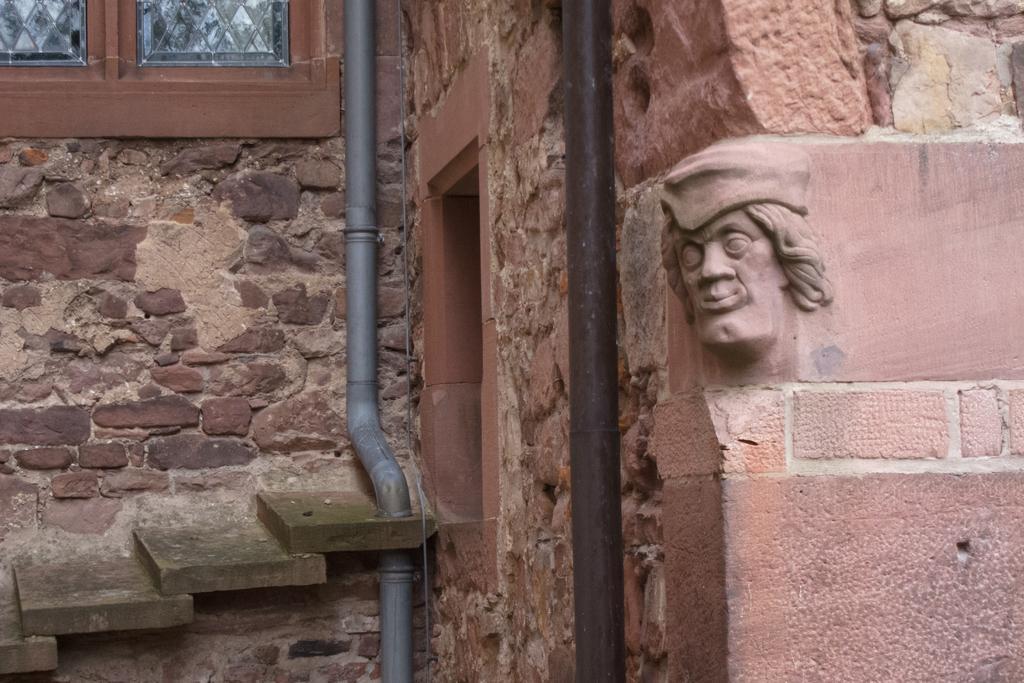How would you summarize this image in a sentence or two? On the right side of the image, we can see a sculpture on the wall. In the middle of the picture, we can see pipes. On the left side of the image, we can see stair and window. 